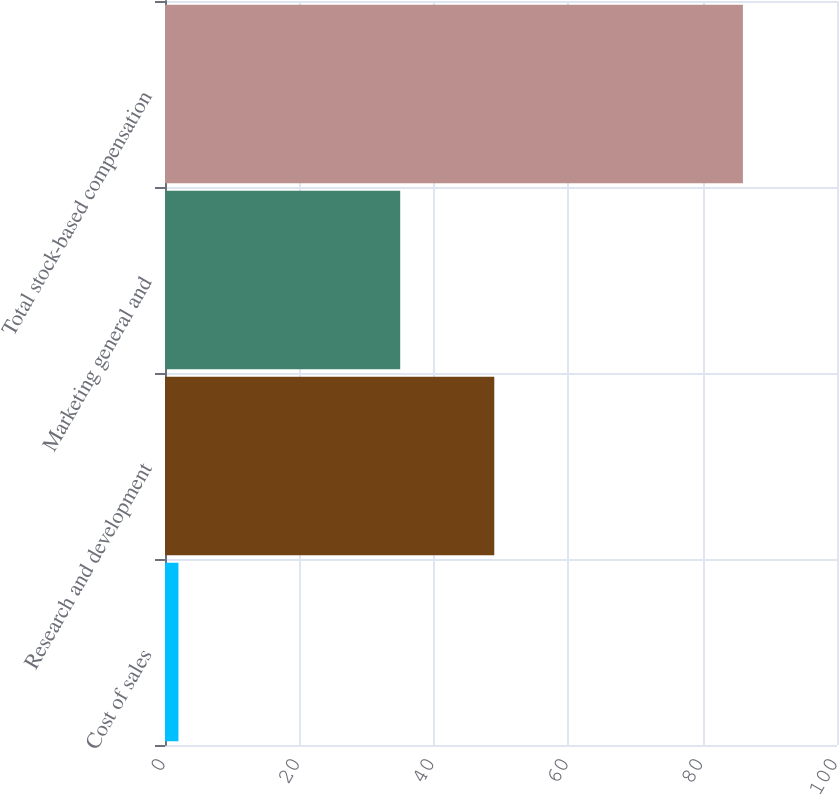Convert chart. <chart><loc_0><loc_0><loc_500><loc_500><bar_chart><fcel>Cost of sales<fcel>Research and development<fcel>Marketing general and<fcel>Total stock-based compensation<nl><fcel>2<fcel>49<fcel>35<fcel>86<nl></chart> 